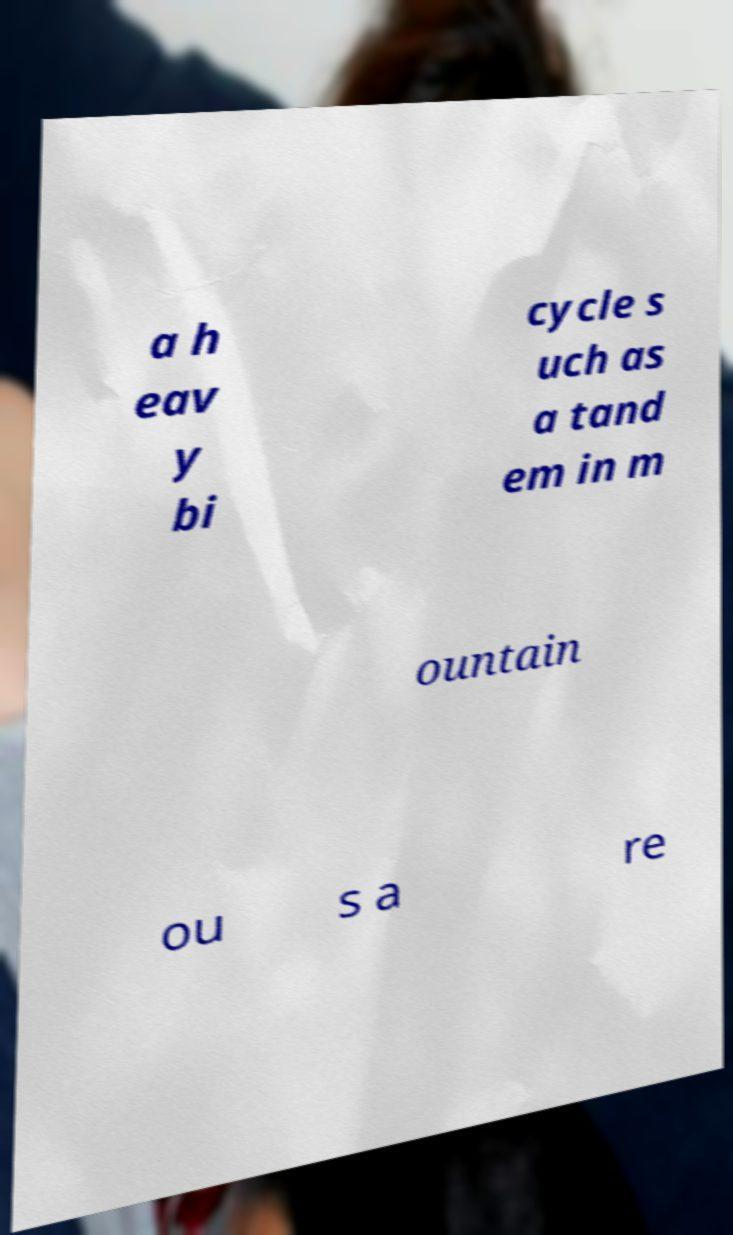Please read and relay the text visible in this image. What does it say? a h eav y bi cycle s uch as a tand em in m ountain ou s a re 